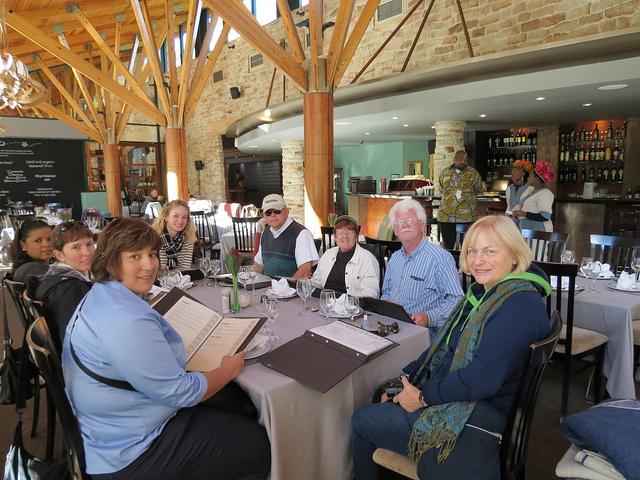Is the wall made of brick or stone?
Keep it brief. Brick. Does this appear to be a restaurant or residential dining room?
Quick response, please. Restaurant. What vehicle is this taken in?
Write a very short answer. None. What is around the woman in blues neck?
Be succinct. Scarf. 